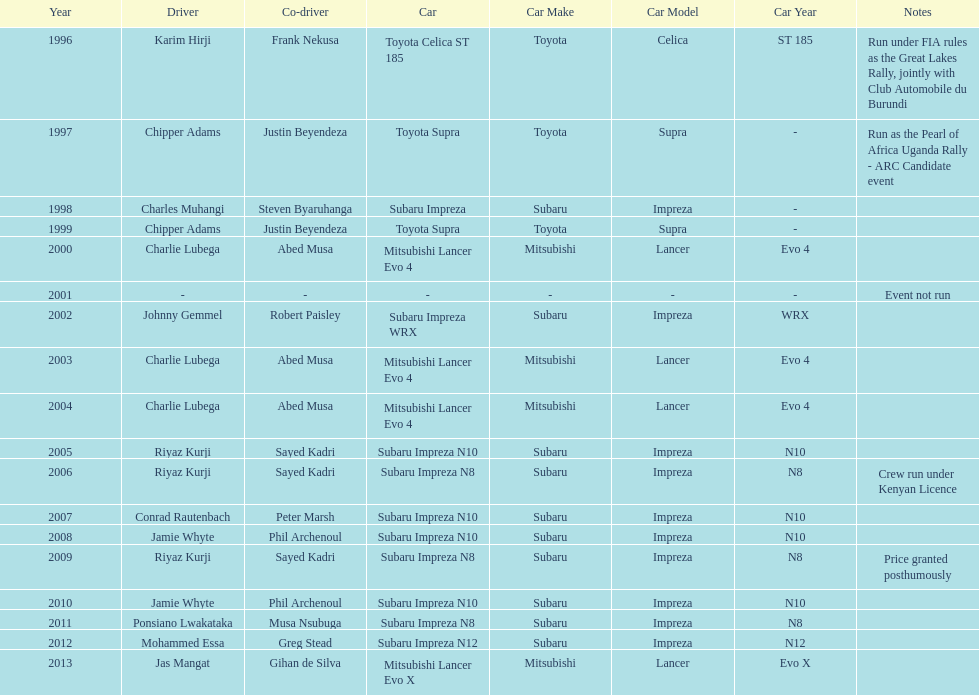In how many instances has the winning driver driven a toyota supra? 2. 